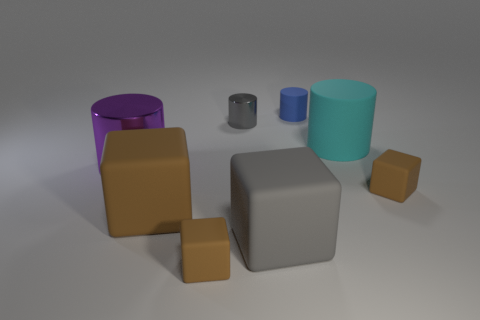There is a small matte thing behind the small gray thing; what is its color?
Provide a succinct answer. Blue. What number of things are the same color as the large metallic cylinder?
Ensure brevity in your answer.  0. What number of cylinders are in front of the tiny gray shiny object and to the left of the tiny rubber cylinder?
Keep it short and to the point. 1. What is the shape of the gray thing that is the same size as the blue cylinder?
Provide a short and direct response. Cylinder. What size is the cyan rubber cylinder?
Offer a very short reply. Large. There is a brown object that is on the right side of the large cyan cylinder that is in front of the matte cylinder that is behind the small metal cylinder; what is it made of?
Give a very brief answer. Rubber. There is another big cylinder that is made of the same material as the blue cylinder; what color is it?
Keep it short and to the point. Cyan. What number of gray objects are right of the brown matte thing to the right of the large cube to the right of the big brown thing?
Keep it short and to the point. 0. There is a large block that is the same color as the small metallic thing; what is its material?
Provide a succinct answer. Rubber. Are there any other things that have the same shape as the small blue rubber object?
Your answer should be compact. Yes. 